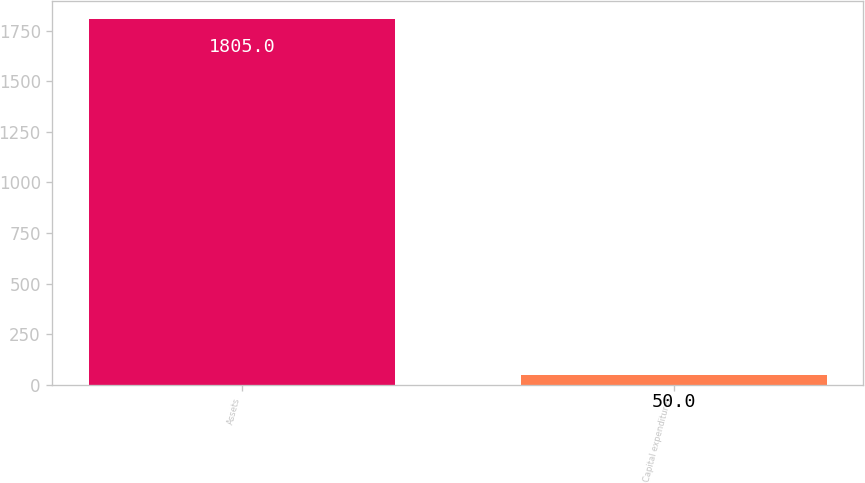Convert chart. <chart><loc_0><loc_0><loc_500><loc_500><bar_chart><fcel>Assets<fcel>Capital expenditures<nl><fcel>1805<fcel>50<nl></chart> 